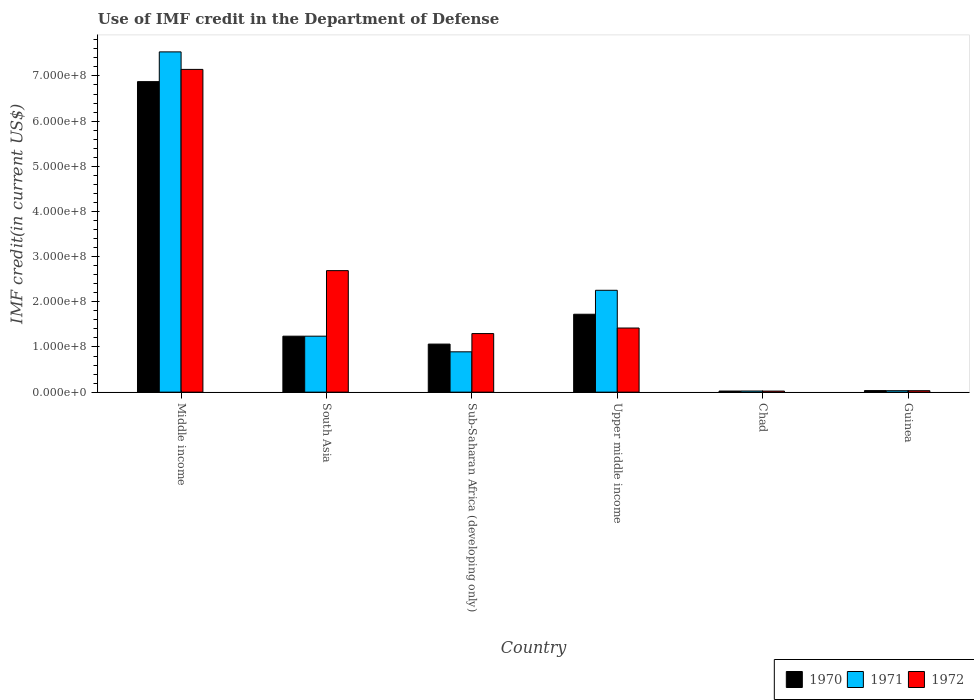How many groups of bars are there?
Your response must be concise. 6. Are the number of bars per tick equal to the number of legend labels?
Provide a short and direct response. Yes. Are the number of bars on each tick of the X-axis equal?
Provide a succinct answer. Yes. How many bars are there on the 3rd tick from the right?
Offer a terse response. 3. What is the label of the 6th group of bars from the left?
Provide a short and direct response. Guinea. What is the IMF credit in the Department of Defense in 1971 in Chad?
Offer a very short reply. 2.52e+06. Across all countries, what is the maximum IMF credit in the Department of Defense in 1972?
Make the answer very short. 7.14e+08. Across all countries, what is the minimum IMF credit in the Department of Defense in 1971?
Offer a very short reply. 2.52e+06. In which country was the IMF credit in the Department of Defense in 1972 minimum?
Keep it short and to the point. Chad. What is the total IMF credit in the Department of Defense in 1971 in the graph?
Your answer should be very brief. 1.20e+09. What is the difference between the IMF credit in the Department of Defense in 1970 in Chad and that in Middle income?
Offer a very short reply. -6.85e+08. What is the difference between the IMF credit in the Department of Defense in 1970 in South Asia and the IMF credit in the Department of Defense in 1971 in Chad?
Your answer should be compact. 1.21e+08. What is the average IMF credit in the Department of Defense in 1972 per country?
Keep it short and to the point. 2.10e+08. What is the difference between the IMF credit in the Department of Defense of/in 1970 and IMF credit in the Department of Defense of/in 1971 in Upper middle income?
Offer a terse response. -5.30e+07. What is the ratio of the IMF credit in the Department of Defense in 1971 in Chad to that in South Asia?
Provide a short and direct response. 0.02. Is the difference between the IMF credit in the Department of Defense in 1970 in Chad and Middle income greater than the difference between the IMF credit in the Department of Defense in 1971 in Chad and Middle income?
Keep it short and to the point. Yes. What is the difference between the highest and the second highest IMF credit in the Department of Defense in 1972?
Give a very brief answer. -4.45e+08. What is the difference between the highest and the lowest IMF credit in the Department of Defense in 1970?
Give a very brief answer. 6.85e+08. In how many countries, is the IMF credit in the Department of Defense in 1971 greater than the average IMF credit in the Department of Defense in 1971 taken over all countries?
Give a very brief answer. 2. What does the 3rd bar from the right in Chad represents?
Give a very brief answer. 1970. How many bars are there?
Your answer should be compact. 18. Are the values on the major ticks of Y-axis written in scientific E-notation?
Make the answer very short. Yes. Does the graph contain grids?
Provide a short and direct response. No. Where does the legend appear in the graph?
Keep it short and to the point. Bottom right. How are the legend labels stacked?
Make the answer very short. Horizontal. What is the title of the graph?
Make the answer very short. Use of IMF credit in the Department of Defense. Does "2005" appear as one of the legend labels in the graph?
Ensure brevity in your answer.  No. What is the label or title of the Y-axis?
Your answer should be compact. IMF credit(in current US$). What is the IMF credit(in current US$) of 1970 in Middle income?
Your response must be concise. 6.87e+08. What is the IMF credit(in current US$) in 1971 in Middle income?
Your answer should be very brief. 7.53e+08. What is the IMF credit(in current US$) in 1972 in Middle income?
Your answer should be compact. 7.14e+08. What is the IMF credit(in current US$) of 1970 in South Asia?
Give a very brief answer. 1.24e+08. What is the IMF credit(in current US$) of 1971 in South Asia?
Provide a short and direct response. 1.24e+08. What is the IMF credit(in current US$) of 1972 in South Asia?
Give a very brief answer. 2.69e+08. What is the IMF credit(in current US$) in 1970 in Sub-Saharan Africa (developing only)?
Offer a very short reply. 1.06e+08. What is the IMF credit(in current US$) in 1971 in Sub-Saharan Africa (developing only)?
Provide a succinct answer. 8.93e+07. What is the IMF credit(in current US$) of 1972 in Sub-Saharan Africa (developing only)?
Your answer should be very brief. 1.30e+08. What is the IMF credit(in current US$) in 1970 in Upper middle income?
Provide a succinct answer. 1.72e+08. What is the IMF credit(in current US$) of 1971 in Upper middle income?
Your answer should be very brief. 2.25e+08. What is the IMF credit(in current US$) of 1972 in Upper middle income?
Your response must be concise. 1.42e+08. What is the IMF credit(in current US$) in 1970 in Chad?
Provide a short and direct response. 2.47e+06. What is the IMF credit(in current US$) in 1971 in Chad?
Provide a succinct answer. 2.52e+06. What is the IMF credit(in current US$) in 1972 in Chad?
Your answer should be very brief. 2.37e+06. What is the IMF credit(in current US$) in 1970 in Guinea?
Your answer should be compact. 3.45e+06. What is the IMF credit(in current US$) of 1971 in Guinea?
Offer a very short reply. 3.20e+06. What is the IMF credit(in current US$) of 1972 in Guinea?
Your answer should be compact. 3.20e+06. Across all countries, what is the maximum IMF credit(in current US$) in 1970?
Provide a succinct answer. 6.87e+08. Across all countries, what is the maximum IMF credit(in current US$) in 1971?
Offer a terse response. 7.53e+08. Across all countries, what is the maximum IMF credit(in current US$) in 1972?
Give a very brief answer. 7.14e+08. Across all countries, what is the minimum IMF credit(in current US$) of 1970?
Make the answer very short. 2.47e+06. Across all countries, what is the minimum IMF credit(in current US$) of 1971?
Provide a short and direct response. 2.52e+06. Across all countries, what is the minimum IMF credit(in current US$) in 1972?
Provide a short and direct response. 2.37e+06. What is the total IMF credit(in current US$) of 1970 in the graph?
Your response must be concise. 1.10e+09. What is the total IMF credit(in current US$) in 1971 in the graph?
Make the answer very short. 1.20e+09. What is the total IMF credit(in current US$) of 1972 in the graph?
Provide a succinct answer. 1.26e+09. What is the difference between the IMF credit(in current US$) in 1970 in Middle income and that in South Asia?
Provide a succinct answer. 5.64e+08. What is the difference between the IMF credit(in current US$) in 1971 in Middle income and that in South Asia?
Ensure brevity in your answer.  6.29e+08. What is the difference between the IMF credit(in current US$) of 1972 in Middle income and that in South Asia?
Ensure brevity in your answer.  4.45e+08. What is the difference between the IMF credit(in current US$) of 1970 in Middle income and that in Sub-Saharan Africa (developing only)?
Offer a very short reply. 5.81e+08. What is the difference between the IMF credit(in current US$) in 1971 in Middle income and that in Sub-Saharan Africa (developing only)?
Your response must be concise. 6.64e+08. What is the difference between the IMF credit(in current US$) in 1972 in Middle income and that in Sub-Saharan Africa (developing only)?
Provide a short and direct response. 5.85e+08. What is the difference between the IMF credit(in current US$) of 1970 in Middle income and that in Upper middle income?
Offer a very short reply. 5.15e+08. What is the difference between the IMF credit(in current US$) in 1971 in Middle income and that in Upper middle income?
Your answer should be compact. 5.28e+08. What is the difference between the IMF credit(in current US$) of 1972 in Middle income and that in Upper middle income?
Make the answer very short. 5.73e+08. What is the difference between the IMF credit(in current US$) in 1970 in Middle income and that in Chad?
Provide a succinct answer. 6.85e+08. What is the difference between the IMF credit(in current US$) of 1971 in Middle income and that in Chad?
Offer a terse response. 7.51e+08. What is the difference between the IMF credit(in current US$) in 1972 in Middle income and that in Chad?
Provide a short and direct response. 7.12e+08. What is the difference between the IMF credit(in current US$) in 1970 in Middle income and that in Guinea?
Provide a succinct answer. 6.84e+08. What is the difference between the IMF credit(in current US$) in 1971 in Middle income and that in Guinea?
Ensure brevity in your answer.  7.50e+08. What is the difference between the IMF credit(in current US$) in 1972 in Middle income and that in Guinea?
Make the answer very short. 7.11e+08. What is the difference between the IMF credit(in current US$) of 1970 in South Asia and that in Sub-Saharan Africa (developing only)?
Ensure brevity in your answer.  1.75e+07. What is the difference between the IMF credit(in current US$) of 1971 in South Asia and that in Sub-Saharan Africa (developing only)?
Provide a succinct answer. 3.46e+07. What is the difference between the IMF credit(in current US$) in 1972 in South Asia and that in Sub-Saharan Africa (developing only)?
Keep it short and to the point. 1.39e+08. What is the difference between the IMF credit(in current US$) of 1970 in South Asia and that in Upper middle income?
Offer a terse response. -4.86e+07. What is the difference between the IMF credit(in current US$) in 1971 in South Asia and that in Upper middle income?
Give a very brief answer. -1.02e+08. What is the difference between the IMF credit(in current US$) in 1972 in South Asia and that in Upper middle income?
Provide a short and direct response. 1.27e+08. What is the difference between the IMF credit(in current US$) of 1970 in South Asia and that in Chad?
Provide a short and direct response. 1.21e+08. What is the difference between the IMF credit(in current US$) of 1971 in South Asia and that in Chad?
Ensure brevity in your answer.  1.21e+08. What is the difference between the IMF credit(in current US$) of 1972 in South Asia and that in Chad?
Your answer should be compact. 2.67e+08. What is the difference between the IMF credit(in current US$) in 1970 in South Asia and that in Guinea?
Provide a succinct answer. 1.20e+08. What is the difference between the IMF credit(in current US$) of 1971 in South Asia and that in Guinea?
Make the answer very short. 1.21e+08. What is the difference between the IMF credit(in current US$) in 1972 in South Asia and that in Guinea?
Provide a short and direct response. 2.66e+08. What is the difference between the IMF credit(in current US$) in 1970 in Sub-Saharan Africa (developing only) and that in Upper middle income?
Your answer should be very brief. -6.61e+07. What is the difference between the IMF credit(in current US$) of 1971 in Sub-Saharan Africa (developing only) and that in Upper middle income?
Provide a short and direct response. -1.36e+08. What is the difference between the IMF credit(in current US$) in 1972 in Sub-Saharan Africa (developing only) and that in Upper middle income?
Your answer should be compact. -1.23e+07. What is the difference between the IMF credit(in current US$) in 1970 in Sub-Saharan Africa (developing only) and that in Chad?
Your answer should be very brief. 1.04e+08. What is the difference between the IMF credit(in current US$) in 1971 in Sub-Saharan Africa (developing only) and that in Chad?
Ensure brevity in your answer.  8.68e+07. What is the difference between the IMF credit(in current US$) of 1972 in Sub-Saharan Africa (developing only) and that in Chad?
Provide a short and direct response. 1.27e+08. What is the difference between the IMF credit(in current US$) in 1970 in Sub-Saharan Africa (developing only) and that in Guinea?
Your answer should be very brief. 1.03e+08. What is the difference between the IMF credit(in current US$) of 1971 in Sub-Saharan Africa (developing only) and that in Guinea?
Provide a succinct answer. 8.61e+07. What is the difference between the IMF credit(in current US$) of 1972 in Sub-Saharan Africa (developing only) and that in Guinea?
Keep it short and to the point. 1.26e+08. What is the difference between the IMF credit(in current US$) in 1970 in Upper middle income and that in Chad?
Ensure brevity in your answer.  1.70e+08. What is the difference between the IMF credit(in current US$) in 1971 in Upper middle income and that in Chad?
Your response must be concise. 2.23e+08. What is the difference between the IMF credit(in current US$) in 1972 in Upper middle income and that in Chad?
Offer a terse response. 1.40e+08. What is the difference between the IMF credit(in current US$) in 1970 in Upper middle income and that in Guinea?
Provide a short and direct response. 1.69e+08. What is the difference between the IMF credit(in current US$) of 1971 in Upper middle income and that in Guinea?
Ensure brevity in your answer.  2.22e+08. What is the difference between the IMF credit(in current US$) of 1972 in Upper middle income and that in Guinea?
Give a very brief answer. 1.39e+08. What is the difference between the IMF credit(in current US$) in 1970 in Chad and that in Guinea?
Your response must be concise. -9.80e+05. What is the difference between the IMF credit(in current US$) of 1971 in Chad and that in Guinea?
Provide a short and direct response. -6.84e+05. What is the difference between the IMF credit(in current US$) of 1972 in Chad and that in Guinea?
Provide a short and direct response. -8.36e+05. What is the difference between the IMF credit(in current US$) in 1970 in Middle income and the IMF credit(in current US$) in 1971 in South Asia?
Make the answer very short. 5.64e+08. What is the difference between the IMF credit(in current US$) of 1970 in Middle income and the IMF credit(in current US$) of 1972 in South Asia?
Offer a very short reply. 4.18e+08. What is the difference between the IMF credit(in current US$) in 1971 in Middle income and the IMF credit(in current US$) in 1972 in South Asia?
Make the answer very short. 4.84e+08. What is the difference between the IMF credit(in current US$) in 1970 in Middle income and the IMF credit(in current US$) in 1971 in Sub-Saharan Africa (developing only)?
Offer a very short reply. 5.98e+08. What is the difference between the IMF credit(in current US$) of 1970 in Middle income and the IMF credit(in current US$) of 1972 in Sub-Saharan Africa (developing only)?
Your answer should be compact. 5.58e+08. What is the difference between the IMF credit(in current US$) in 1971 in Middle income and the IMF credit(in current US$) in 1972 in Sub-Saharan Africa (developing only)?
Give a very brief answer. 6.24e+08. What is the difference between the IMF credit(in current US$) of 1970 in Middle income and the IMF credit(in current US$) of 1971 in Upper middle income?
Keep it short and to the point. 4.62e+08. What is the difference between the IMF credit(in current US$) in 1970 in Middle income and the IMF credit(in current US$) in 1972 in Upper middle income?
Your answer should be very brief. 5.45e+08. What is the difference between the IMF credit(in current US$) of 1971 in Middle income and the IMF credit(in current US$) of 1972 in Upper middle income?
Make the answer very short. 6.11e+08. What is the difference between the IMF credit(in current US$) in 1970 in Middle income and the IMF credit(in current US$) in 1971 in Chad?
Offer a very short reply. 6.85e+08. What is the difference between the IMF credit(in current US$) in 1970 in Middle income and the IMF credit(in current US$) in 1972 in Chad?
Provide a short and direct response. 6.85e+08. What is the difference between the IMF credit(in current US$) in 1971 in Middle income and the IMF credit(in current US$) in 1972 in Chad?
Provide a succinct answer. 7.51e+08. What is the difference between the IMF credit(in current US$) of 1970 in Middle income and the IMF credit(in current US$) of 1971 in Guinea?
Provide a succinct answer. 6.84e+08. What is the difference between the IMF credit(in current US$) of 1970 in Middle income and the IMF credit(in current US$) of 1972 in Guinea?
Offer a terse response. 6.84e+08. What is the difference between the IMF credit(in current US$) of 1971 in Middle income and the IMF credit(in current US$) of 1972 in Guinea?
Your answer should be very brief. 7.50e+08. What is the difference between the IMF credit(in current US$) of 1970 in South Asia and the IMF credit(in current US$) of 1971 in Sub-Saharan Africa (developing only)?
Offer a very short reply. 3.46e+07. What is the difference between the IMF credit(in current US$) of 1970 in South Asia and the IMF credit(in current US$) of 1972 in Sub-Saharan Africa (developing only)?
Ensure brevity in your answer.  -5.79e+06. What is the difference between the IMF credit(in current US$) in 1971 in South Asia and the IMF credit(in current US$) in 1972 in Sub-Saharan Africa (developing only)?
Your response must be concise. -5.79e+06. What is the difference between the IMF credit(in current US$) of 1970 in South Asia and the IMF credit(in current US$) of 1971 in Upper middle income?
Your answer should be very brief. -1.02e+08. What is the difference between the IMF credit(in current US$) of 1970 in South Asia and the IMF credit(in current US$) of 1972 in Upper middle income?
Offer a terse response. -1.80e+07. What is the difference between the IMF credit(in current US$) of 1971 in South Asia and the IMF credit(in current US$) of 1972 in Upper middle income?
Keep it short and to the point. -1.80e+07. What is the difference between the IMF credit(in current US$) in 1970 in South Asia and the IMF credit(in current US$) in 1971 in Chad?
Give a very brief answer. 1.21e+08. What is the difference between the IMF credit(in current US$) of 1970 in South Asia and the IMF credit(in current US$) of 1972 in Chad?
Offer a terse response. 1.22e+08. What is the difference between the IMF credit(in current US$) in 1971 in South Asia and the IMF credit(in current US$) in 1972 in Chad?
Make the answer very short. 1.22e+08. What is the difference between the IMF credit(in current US$) of 1970 in South Asia and the IMF credit(in current US$) of 1971 in Guinea?
Offer a terse response. 1.21e+08. What is the difference between the IMF credit(in current US$) of 1970 in South Asia and the IMF credit(in current US$) of 1972 in Guinea?
Your answer should be compact. 1.21e+08. What is the difference between the IMF credit(in current US$) in 1971 in South Asia and the IMF credit(in current US$) in 1972 in Guinea?
Offer a terse response. 1.21e+08. What is the difference between the IMF credit(in current US$) in 1970 in Sub-Saharan Africa (developing only) and the IMF credit(in current US$) in 1971 in Upper middle income?
Make the answer very short. -1.19e+08. What is the difference between the IMF credit(in current US$) in 1970 in Sub-Saharan Africa (developing only) and the IMF credit(in current US$) in 1972 in Upper middle income?
Your answer should be compact. -3.56e+07. What is the difference between the IMF credit(in current US$) of 1971 in Sub-Saharan Africa (developing only) and the IMF credit(in current US$) of 1972 in Upper middle income?
Provide a succinct answer. -5.27e+07. What is the difference between the IMF credit(in current US$) in 1970 in Sub-Saharan Africa (developing only) and the IMF credit(in current US$) in 1971 in Chad?
Provide a short and direct response. 1.04e+08. What is the difference between the IMF credit(in current US$) of 1970 in Sub-Saharan Africa (developing only) and the IMF credit(in current US$) of 1972 in Chad?
Your answer should be very brief. 1.04e+08. What is the difference between the IMF credit(in current US$) in 1971 in Sub-Saharan Africa (developing only) and the IMF credit(in current US$) in 1972 in Chad?
Make the answer very short. 8.69e+07. What is the difference between the IMF credit(in current US$) in 1970 in Sub-Saharan Africa (developing only) and the IMF credit(in current US$) in 1971 in Guinea?
Offer a terse response. 1.03e+08. What is the difference between the IMF credit(in current US$) of 1970 in Sub-Saharan Africa (developing only) and the IMF credit(in current US$) of 1972 in Guinea?
Offer a terse response. 1.03e+08. What is the difference between the IMF credit(in current US$) in 1971 in Sub-Saharan Africa (developing only) and the IMF credit(in current US$) in 1972 in Guinea?
Offer a very short reply. 8.61e+07. What is the difference between the IMF credit(in current US$) in 1970 in Upper middle income and the IMF credit(in current US$) in 1971 in Chad?
Offer a terse response. 1.70e+08. What is the difference between the IMF credit(in current US$) of 1970 in Upper middle income and the IMF credit(in current US$) of 1972 in Chad?
Give a very brief answer. 1.70e+08. What is the difference between the IMF credit(in current US$) in 1971 in Upper middle income and the IMF credit(in current US$) in 1972 in Chad?
Offer a terse response. 2.23e+08. What is the difference between the IMF credit(in current US$) of 1970 in Upper middle income and the IMF credit(in current US$) of 1971 in Guinea?
Your response must be concise. 1.69e+08. What is the difference between the IMF credit(in current US$) in 1970 in Upper middle income and the IMF credit(in current US$) in 1972 in Guinea?
Offer a very short reply. 1.69e+08. What is the difference between the IMF credit(in current US$) of 1971 in Upper middle income and the IMF credit(in current US$) of 1972 in Guinea?
Your response must be concise. 2.22e+08. What is the difference between the IMF credit(in current US$) in 1970 in Chad and the IMF credit(in current US$) in 1971 in Guinea?
Make the answer very short. -7.33e+05. What is the difference between the IMF credit(in current US$) in 1970 in Chad and the IMF credit(in current US$) in 1972 in Guinea?
Offer a terse response. -7.33e+05. What is the difference between the IMF credit(in current US$) in 1971 in Chad and the IMF credit(in current US$) in 1972 in Guinea?
Your response must be concise. -6.84e+05. What is the average IMF credit(in current US$) in 1970 per country?
Provide a short and direct response. 1.83e+08. What is the average IMF credit(in current US$) in 1971 per country?
Make the answer very short. 2.00e+08. What is the average IMF credit(in current US$) of 1972 per country?
Ensure brevity in your answer.  2.10e+08. What is the difference between the IMF credit(in current US$) of 1970 and IMF credit(in current US$) of 1971 in Middle income?
Make the answer very short. -6.58e+07. What is the difference between the IMF credit(in current US$) in 1970 and IMF credit(in current US$) in 1972 in Middle income?
Provide a short and direct response. -2.71e+07. What is the difference between the IMF credit(in current US$) in 1971 and IMF credit(in current US$) in 1972 in Middle income?
Provide a short and direct response. 3.88e+07. What is the difference between the IMF credit(in current US$) in 1970 and IMF credit(in current US$) in 1971 in South Asia?
Ensure brevity in your answer.  0. What is the difference between the IMF credit(in current US$) of 1970 and IMF credit(in current US$) of 1972 in South Asia?
Give a very brief answer. -1.45e+08. What is the difference between the IMF credit(in current US$) of 1971 and IMF credit(in current US$) of 1972 in South Asia?
Your response must be concise. -1.45e+08. What is the difference between the IMF credit(in current US$) in 1970 and IMF credit(in current US$) in 1971 in Sub-Saharan Africa (developing only)?
Your answer should be compact. 1.71e+07. What is the difference between the IMF credit(in current US$) of 1970 and IMF credit(in current US$) of 1972 in Sub-Saharan Africa (developing only)?
Your response must be concise. -2.33e+07. What is the difference between the IMF credit(in current US$) of 1971 and IMF credit(in current US$) of 1972 in Sub-Saharan Africa (developing only)?
Provide a succinct answer. -4.04e+07. What is the difference between the IMF credit(in current US$) in 1970 and IMF credit(in current US$) in 1971 in Upper middle income?
Your response must be concise. -5.30e+07. What is the difference between the IMF credit(in current US$) of 1970 and IMF credit(in current US$) of 1972 in Upper middle income?
Provide a short and direct response. 3.05e+07. What is the difference between the IMF credit(in current US$) of 1971 and IMF credit(in current US$) of 1972 in Upper middle income?
Your answer should be compact. 8.35e+07. What is the difference between the IMF credit(in current US$) of 1970 and IMF credit(in current US$) of 1971 in Chad?
Make the answer very short. -4.90e+04. What is the difference between the IMF credit(in current US$) in 1970 and IMF credit(in current US$) in 1972 in Chad?
Give a very brief answer. 1.03e+05. What is the difference between the IMF credit(in current US$) in 1971 and IMF credit(in current US$) in 1972 in Chad?
Provide a short and direct response. 1.52e+05. What is the difference between the IMF credit(in current US$) in 1970 and IMF credit(in current US$) in 1971 in Guinea?
Offer a terse response. 2.47e+05. What is the difference between the IMF credit(in current US$) of 1970 and IMF credit(in current US$) of 1972 in Guinea?
Provide a succinct answer. 2.47e+05. What is the ratio of the IMF credit(in current US$) of 1970 in Middle income to that in South Asia?
Ensure brevity in your answer.  5.55. What is the ratio of the IMF credit(in current US$) of 1971 in Middle income to that in South Asia?
Ensure brevity in your answer.  6.08. What is the ratio of the IMF credit(in current US$) of 1972 in Middle income to that in South Asia?
Provide a succinct answer. 2.66. What is the ratio of the IMF credit(in current US$) in 1970 in Middle income to that in Sub-Saharan Africa (developing only)?
Make the answer very short. 6.46. What is the ratio of the IMF credit(in current US$) in 1971 in Middle income to that in Sub-Saharan Africa (developing only)?
Keep it short and to the point. 8.44. What is the ratio of the IMF credit(in current US$) of 1972 in Middle income to that in Sub-Saharan Africa (developing only)?
Make the answer very short. 5.51. What is the ratio of the IMF credit(in current US$) of 1970 in Middle income to that in Upper middle income?
Keep it short and to the point. 3.99. What is the ratio of the IMF credit(in current US$) in 1971 in Middle income to that in Upper middle income?
Your answer should be very brief. 3.34. What is the ratio of the IMF credit(in current US$) in 1972 in Middle income to that in Upper middle income?
Ensure brevity in your answer.  5.03. What is the ratio of the IMF credit(in current US$) of 1970 in Middle income to that in Chad?
Offer a very short reply. 278.3. What is the ratio of the IMF credit(in current US$) of 1971 in Middle income to that in Chad?
Ensure brevity in your answer.  299.03. What is the ratio of the IMF credit(in current US$) of 1972 in Middle income to that in Chad?
Your answer should be compact. 301.85. What is the ratio of the IMF credit(in current US$) in 1970 in Middle income to that in Guinea?
Keep it short and to the point. 199.25. What is the ratio of the IMF credit(in current US$) of 1971 in Middle income to that in Guinea?
Give a very brief answer. 235.17. What is the ratio of the IMF credit(in current US$) of 1972 in Middle income to that in Guinea?
Ensure brevity in your answer.  223.06. What is the ratio of the IMF credit(in current US$) of 1970 in South Asia to that in Sub-Saharan Africa (developing only)?
Provide a short and direct response. 1.16. What is the ratio of the IMF credit(in current US$) of 1971 in South Asia to that in Sub-Saharan Africa (developing only)?
Keep it short and to the point. 1.39. What is the ratio of the IMF credit(in current US$) of 1972 in South Asia to that in Sub-Saharan Africa (developing only)?
Your response must be concise. 2.07. What is the ratio of the IMF credit(in current US$) of 1970 in South Asia to that in Upper middle income?
Your answer should be compact. 0.72. What is the ratio of the IMF credit(in current US$) of 1971 in South Asia to that in Upper middle income?
Keep it short and to the point. 0.55. What is the ratio of the IMF credit(in current US$) in 1972 in South Asia to that in Upper middle income?
Give a very brief answer. 1.9. What is the ratio of the IMF credit(in current US$) of 1970 in South Asia to that in Chad?
Your answer should be compact. 50.16. What is the ratio of the IMF credit(in current US$) in 1971 in South Asia to that in Chad?
Offer a terse response. 49.19. What is the ratio of the IMF credit(in current US$) in 1972 in South Asia to that in Chad?
Ensure brevity in your answer.  113.64. What is the ratio of the IMF credit(in current US$) of 1970 in South Asia to that in Guinea?
Offer a terse response. 35.91. What is the ratio of the IMF credit(in current US$) in 1971 in South Asia to that in Guinea?
Your answer should be very brief. 38.68. What is the ratio of the IMF credit(in current US$) in 1972 in South Asia to that in Guinea?
Give a very brief answer. 83.98. What is the ratio of the IMF credit(in current US$) in 1970 in Sub-Saharan Africa (developing only) to that in Upper middle income?
Your response must be concise. 0.62. What is the ratio of the IMF credit(in current US$) in 1971 in Sub-Saharan Africa (developing only) to that in Upper middle income?
Offer a very short reply. 0.4. What is the ratio of the IMF credit(in current US$) of 1972 in Sub-Saharan Africa (developing only) to that in Upper middle income?
Make the answer very short. 0.91. What is the ratio of the IMF credit(in current US$) of 1970 in Sub-Saharan Africa (developing only) to that in Chad?
Ensure brevity in your answer.  43.07. What is the ratio of the IMF credit(in current US$) of 1971 in Sub-Saharan Africa (developing only) to that in Chad?
Provide a succinct answer. 35.45. What is the ratio of the IMF credit(in current US$) of 1972 in Sub-Saharan Africa (developing only) to that in Chad?
Provide a succinct answer. 54.79. What is the ratio of the IMF credit(in current US$) of 1970 in Sub-Saharan Africa (developing only) to that in Guinea?
Provide a short and direct response. 30.84. What is the ratio of the IMF credit(in current US$) of 1971 in Sub-Saharan Africa (developing only) to that in Guinea?
Offer a terse response. 27.88. What is the ratio of the IMF credit(in current US$) in 1972 in Sub-Saharan Africa (developing only) to that in Guinea?
Keep it short and to the point. 40.49. What is the ratio of the IMF credit(in current US$) of 1970 in Upper middle income to that in Chad?
Make the answer very short. 69.82. What is the ratio of the IMF credit(in current US$) of 1971 in Upper middle income to that in Chad?
Your answer should be very brief. 89.51. What is the ratio of the IMF credit(in current US$) of 1972 in Upper middle income to that in Chad?
Your response must be concise. 59.97. What is the ratio of the IMF credit(in current US$) of 1970 in Upper middle income to that in Guinea?
Provide a succinct answer. 49.99. What is the ratio of the IMF credit(in current US$) in 1971 in Upper middle income to that in Guinea?
Your answer should be very brief. 70.4. What is the ratio of the IMF credit(in current US$) in 1972 in Upper middle income to that in Guinea?
Offer a very short reply. 44.32. What is the ratio of the IMF credit(in current US$) of 1970 in Chad to that in Guinea?
Make the answer very short. 0.72. What is the ratio of the IMF credit(in current US$) in 1971 in Chad to that in Guinea?
Your response must be concise. 0.79. What is the ratio of the IMF credit(in current US$) in 1972 in Chad to that in Guinea?
Provide a short and direct response. 0.74. What is the difference between the highest and the second highest IMF credit(in current US$) in 1970?
Ensure brevity in your answer.  5.15e+08. What is the difference between the highest and the second highest IMF credit(in current US$) of 1971?
Your answer should be very brief. 5.28e+08. What is the difference between the highest and the second highest IMF credit(in current US$) of 1972?
Offer a terse response. 4.45e+08. What is the difference between the highest and the lowest IMF credit(in current US$) in 1970?
Offer a very short reply. 6.85e+08. What is the difference between the highest and the lowest IMF credit(in current US$) in 1971?
Your answer should be compact. 7.51e+08. What is the difference between the highest and the lowest IMF credit(in current US$) of 1972?
Your answer should be very brief. 7.12e+08. 